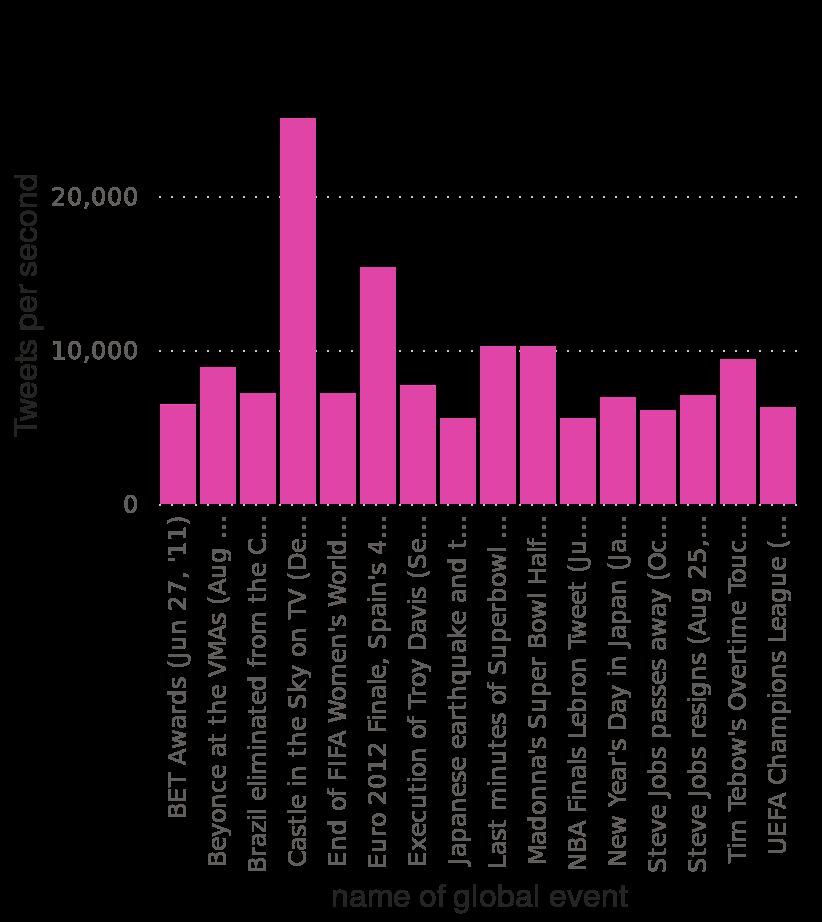<image>
What scale is used on the x-axis of the bar diagram?  The x-axis of the bar diagram uses a categorical scale with the names of global events. What were the two exceptions to most global events having 10,000 or fewer Tweets per second? The two exceptions were the Euro 2012 finale, which had around 15,000 Tweets per second, and Castle in the Sky on TV, which had over 20,000 Tweets per second. What was the average number of Tweets per second for most global events? Most global events had 10,000 or fewer Tweets per second. Which TV show had over 20,000 Tweets per second? Castle in the Sky on TV had over 20,000 Tweets per second. 